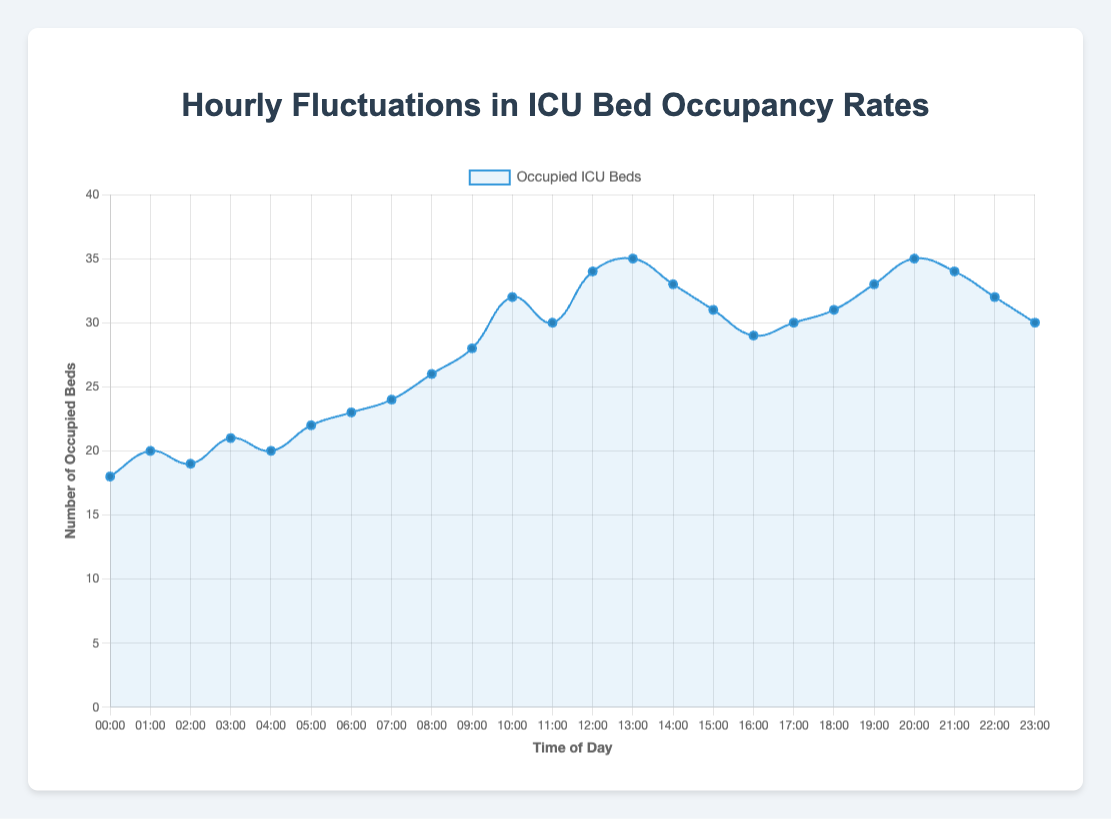What is the bed occupancy rate at 10:00? At 10:00, the graph shows a peak point on the curve. By following the curve upwards from 10:00 on the x-axis, we can see that the number of occupied beds is at 32.
Answer: 32 Which hour has the highest bed occupancy rate? The peak of the curve represents the highest occupancy rate. By examining the curve, we find the highest point occurs at 13:00, where the bed occupancy rate is 35 beds.
Answer: 13:00 What is the average bed occupancy rate from 12:00 to 16:00? Sum up the values from 12:00 to 16:00 (34, 35, 33, 31, 29) which is 34 + 35 + 33 + 31 + 29 = 162. The number of hours is 5. Average = 162/5 = 32.4
Answer: 32.4 How much does the bed occupancy rate change between 03:00 and 06:00? At 03:00, the occupancy rate is 21 beds, and at 06:00, it is 23 beds. The difference is 23 - 21 = 2 beds.
Answer: 2 beds During which hour does the bed occupancy rate first reach 30 beds? By following the curve and identifying the first point at which it reaches 30 on the y-axis, it is at 11:00.
Answer: 11:00 What is the total number of beds occupied from 00:00 to 06:00? Sum up the values from 00:00 to 06:00 (18, 20, 19, 21, 20, 22, 23), which is 18 + 20 + 19 + 21 + 20 + 22 + 23 = 143.
Answer: 143 Compared to 06:00, is the bed occupancy higher or lower at 18:00? At 06:00, the occupancy is 23 beds, and at 18:00, it is 31 beds. Therefore, the occupancy is higher at 18:00.
Answer: Higher By how many beds does the occupancy rate increase from 08:00 to 12:00? At 08:00, the occupancy is 26 beds, and at 12:00, it is 34. The increase is 34 - 26 = 8 beds.
Answer: 8 beds What is the minimum bed occupancy rate and at what hour does this occur? The minimum occupancy rate is depicted by the lowest point on the curve. It occurs at 00:00 with 18 beds.
Answer: 18 beds, 00:00 How does the occupancy rate trend between 16:00 and 23:00? The occupancy rate starts at 29 beds at 16:00, increases gradually, peaking at 35 beds at 20:00, and then decreases steadily to 30 beds by 23:00.
Answer: Increases then decreases 